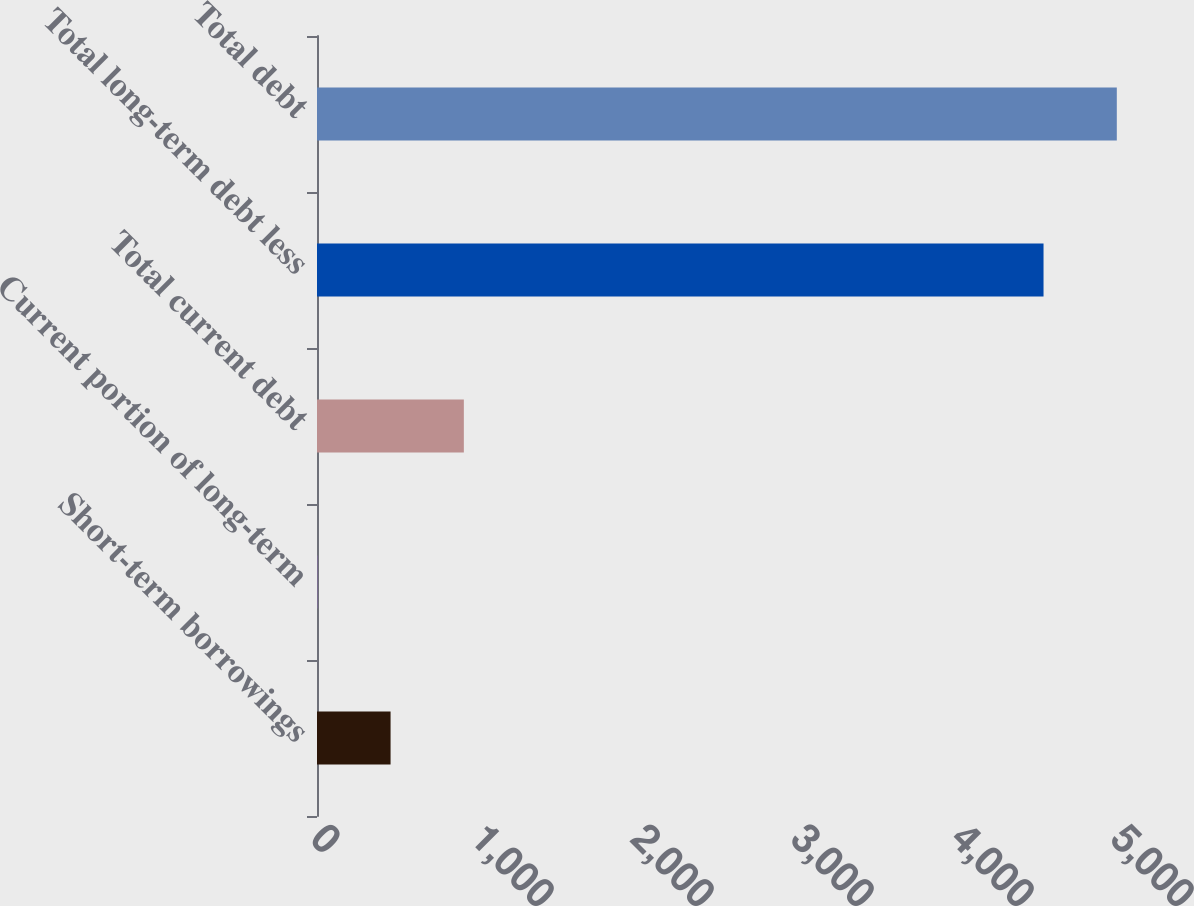Convert chart. <chart><loc_0><loc_0><loc_500><loc_500><bar_chart><fcel>Short-term borrowings<fcel>Current portion of long-term<fcel>Total current debt<fcel>Total long-term debt less<fcel>Total debt<nl><fcel>459.8<fcel>1.8<fcel>917.8<fcel>4540.8<fcel>4998.8<nl></chart> 